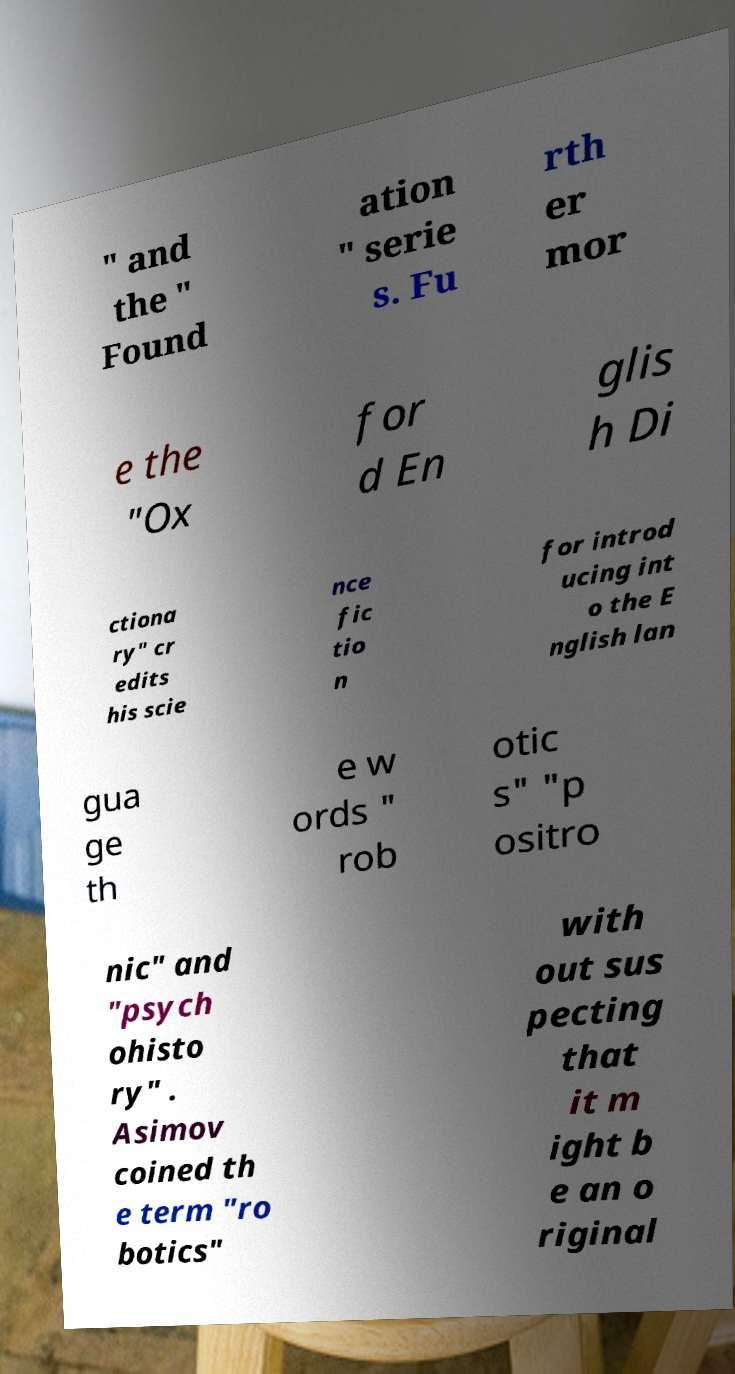Can you accurately transcribe the text from the provided image for me? " and the " Found ation " serie s. Fu rth er mor e the "Ox for d En glis h Di ctiona ry" cr edits his scie nce fic tio n for introd ucing int o the E nglish lan gua ge th e w ords " rob otic s" "p ositro nic" and "psych ohisto ry" . Asimov coined th e term "ro botics" with out sus pecting that it m ight b e an o riginal 